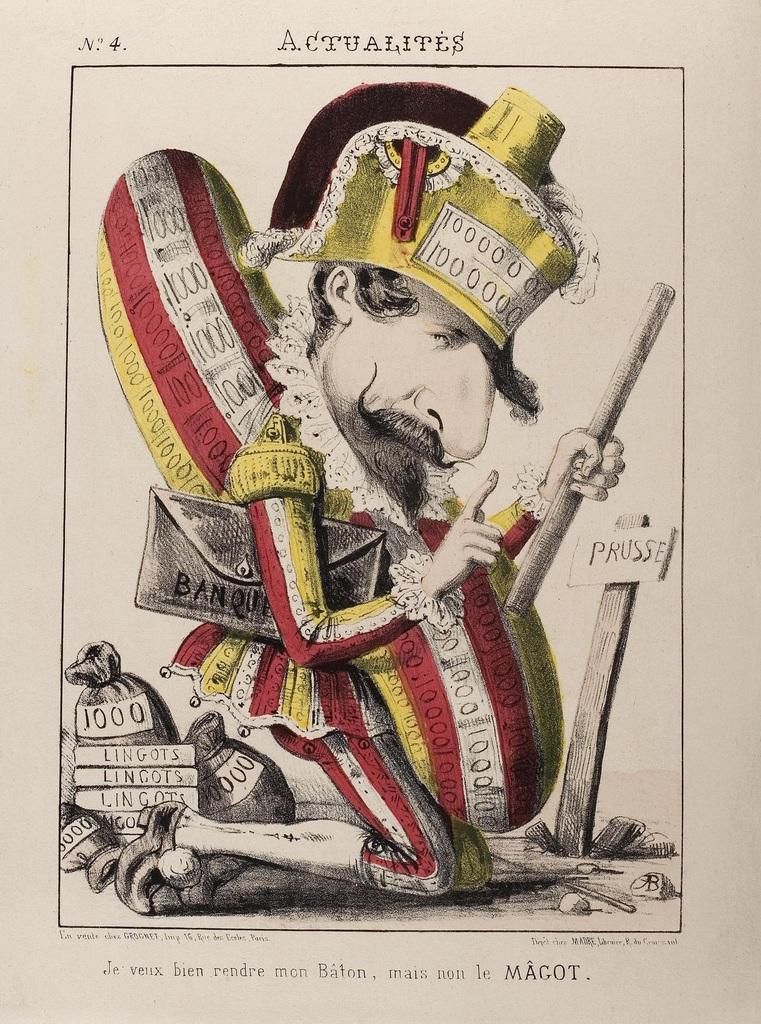What is the main subject of the image? The main subject of the image is a diagram of a man. What is the man wearing in the image? The man is wearing a hat in the image. What type of cracker is the man holding in the image? There is no cracker present in the image; it is a diagram of a man wearing a hat. What tax rate is applied to the man's income in the image? There is no information about taxes or income in the image; it is a diagram of a man wearing a hat. 